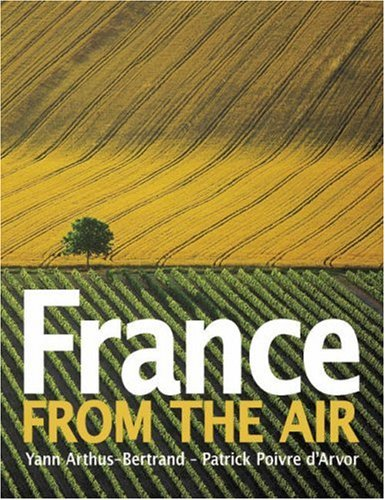Describe the scene shown on the book cover. The cover features a breathtaking aerial view highlighting the contrasting patterns and colors of agricultural fields in France, illustrating nature's beauty intertwined with human cultivation. 